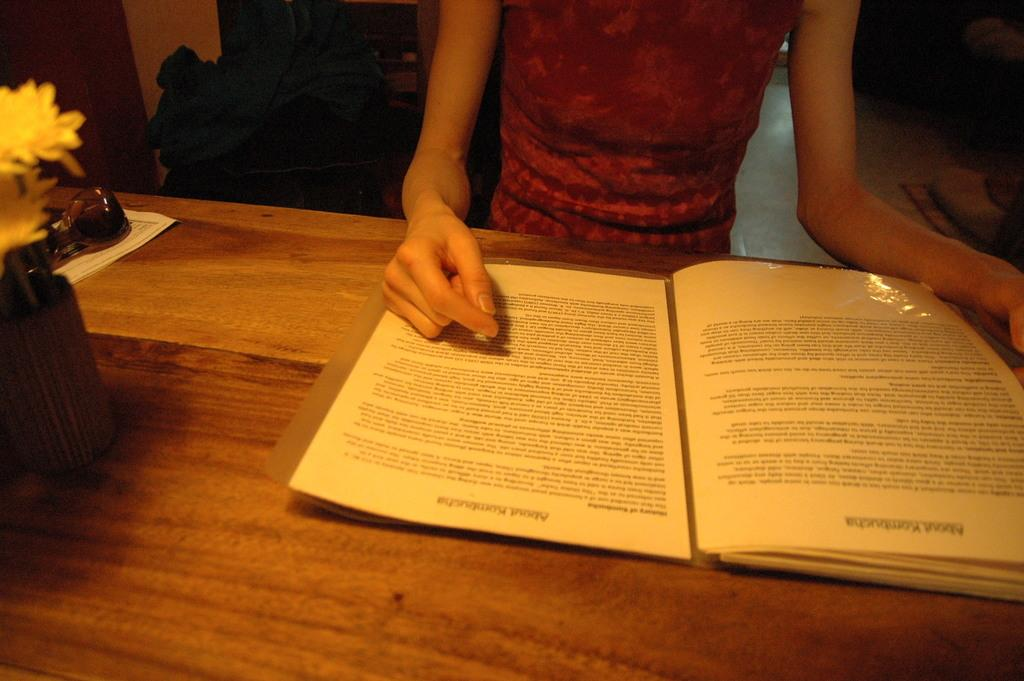What is the person in the image doing? The person in the image is reading a book. Where is the book located in the image? The book is present on a table. What type of footwear is the person wearing while reading the book in the image? There is no information about the person's footwear in the image, so it cannot be determined. 